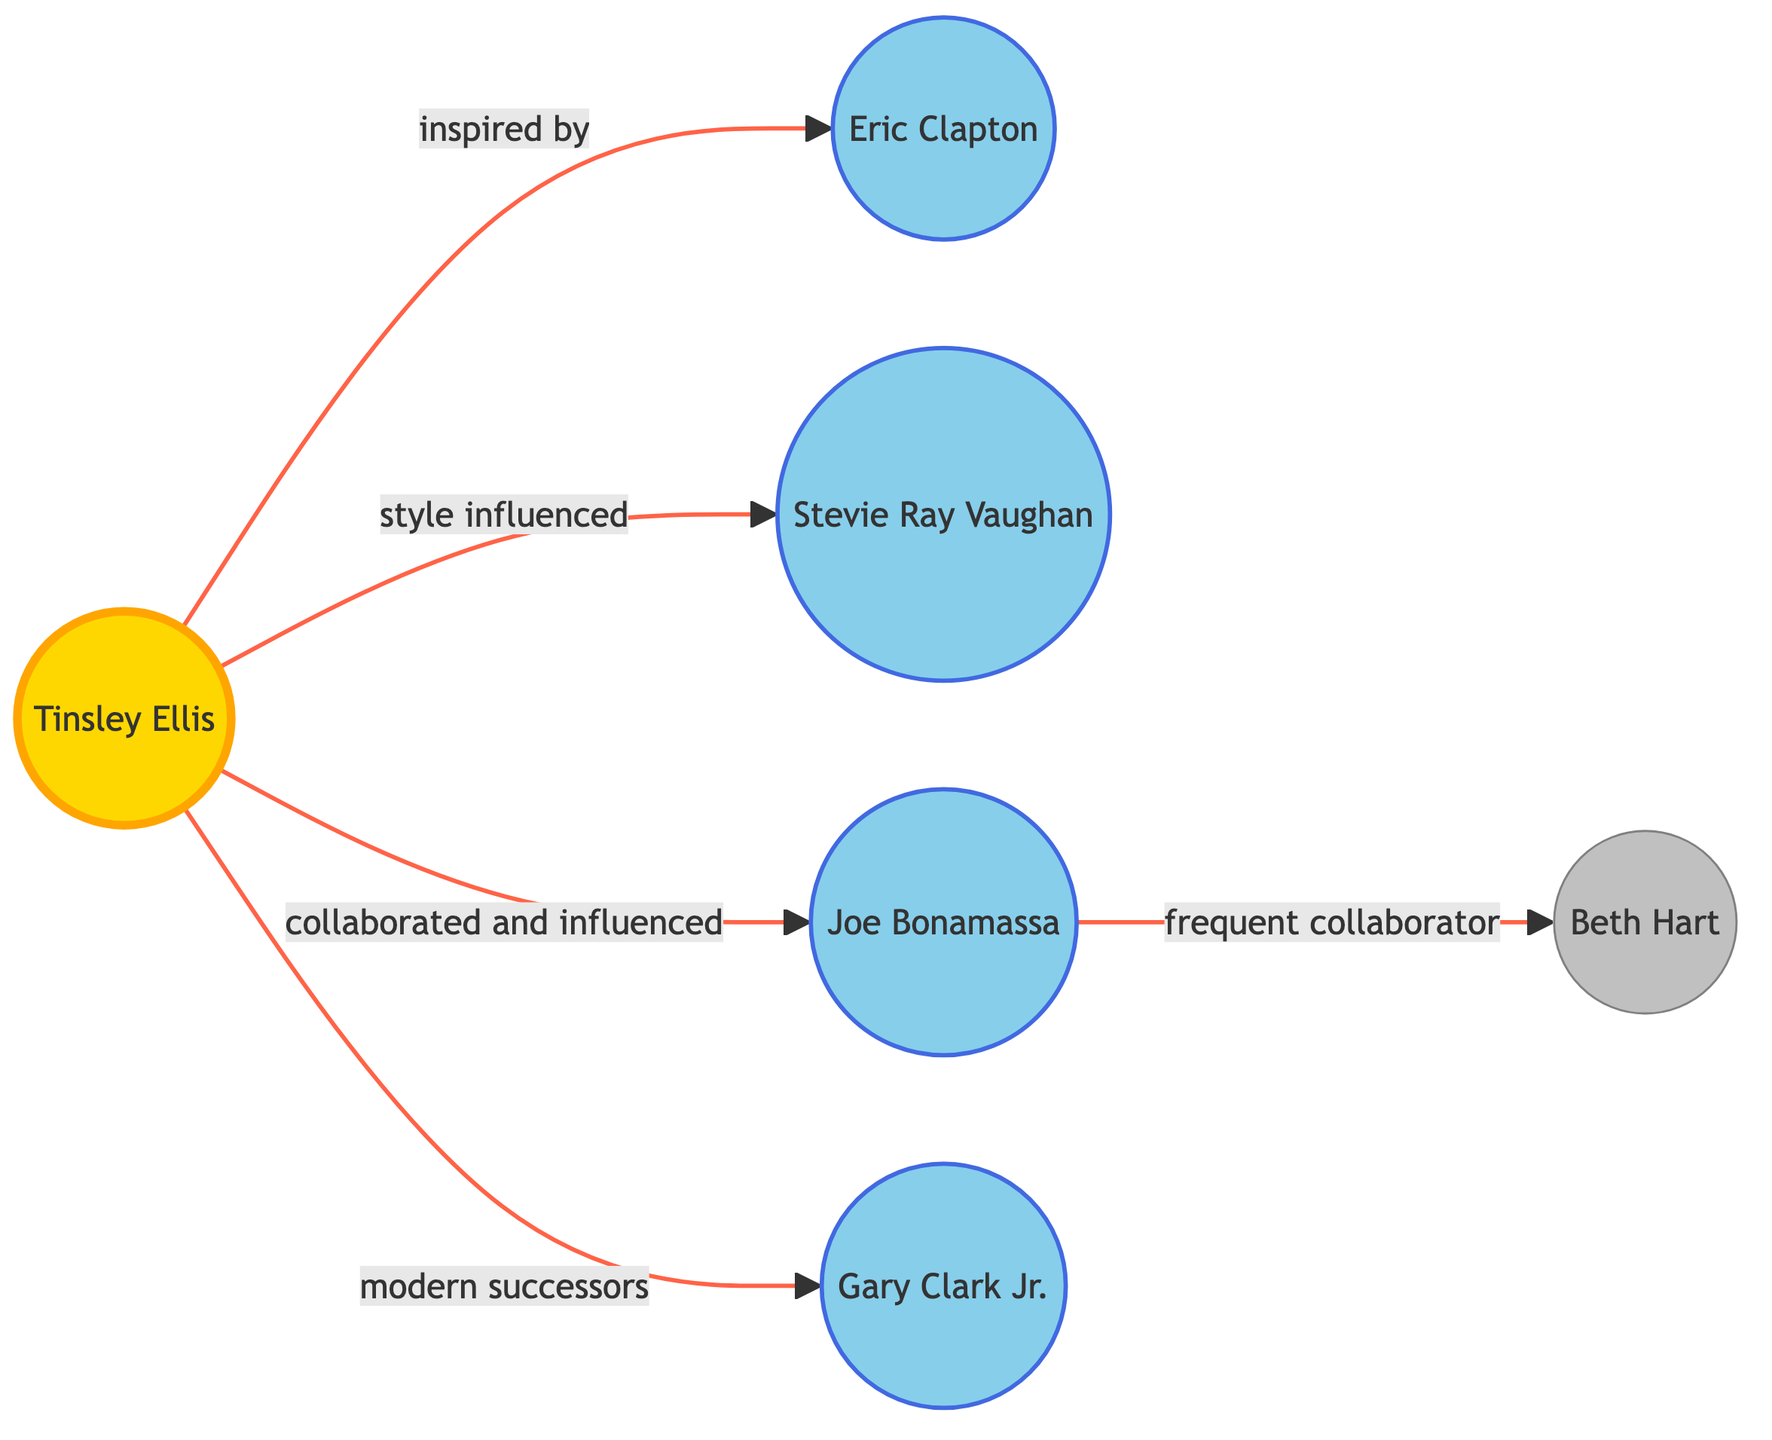What is the central node in the diagram? The central node represents the main star of the diagram and is visually identified as the Sun, which is labeled as "Tinsley Ellis".
Answer: Tinsley Ellis How many planets are directly influenced by the Sun? The diagram displays five planets directly influenced by the Sun, each having a specific connection categorized by different relationships.
Answer: 5 What type of relationship exists between Tinsley Ellis and Joe Bonamassa? The relationship illustrated between Tinsley Ellis (the Sun) and Joe Bonamassa (the Earth) is labeled as "collaborated and influenced", indicating a direct collaboration.
Answer: collaborated and influenced Who is considered a modern successor of Tinsley Ellis? Among the nodes depicted in the diagram, Gary Clark Jr. (Mars) is identified as a modern successor of Tinsley Ellis, illustrating how newer artists draw inspiration from established icons.
Answer: Gary Clark Jr Which artist is depicted as a satellite of Joe Bonamassa? The diagram indicates Beth Hart (the Moon) as a satellite of Joe Bonamassa (the Earth), showing that she is closely associated with him in a collaborative capacity as represented in the diagram.
Answer: Beth Hart How many lines connect Tinsley Ellis to other artists? There are five connecting lines extending from Tinsley Ellis (Sun) to various artists, each representing different types of relationships based on influence and collaboration.
Answer: 5 Which artist has the most significant connection to Tinsley Ellis? Eric Clapton (Mercury) is drawn directly influenced by Tinsley Ellis in terms of inspiration, illustrating significant foundational influence.
Answer: Eric Clapton What does the blue color represent in the diagram? The blue color used throughout the planets indicates that these nodes represent artists who have been influenced by Tinsley Ellis, classifying them as "planets" in this astrology-themed analogy.
Answer: planets 